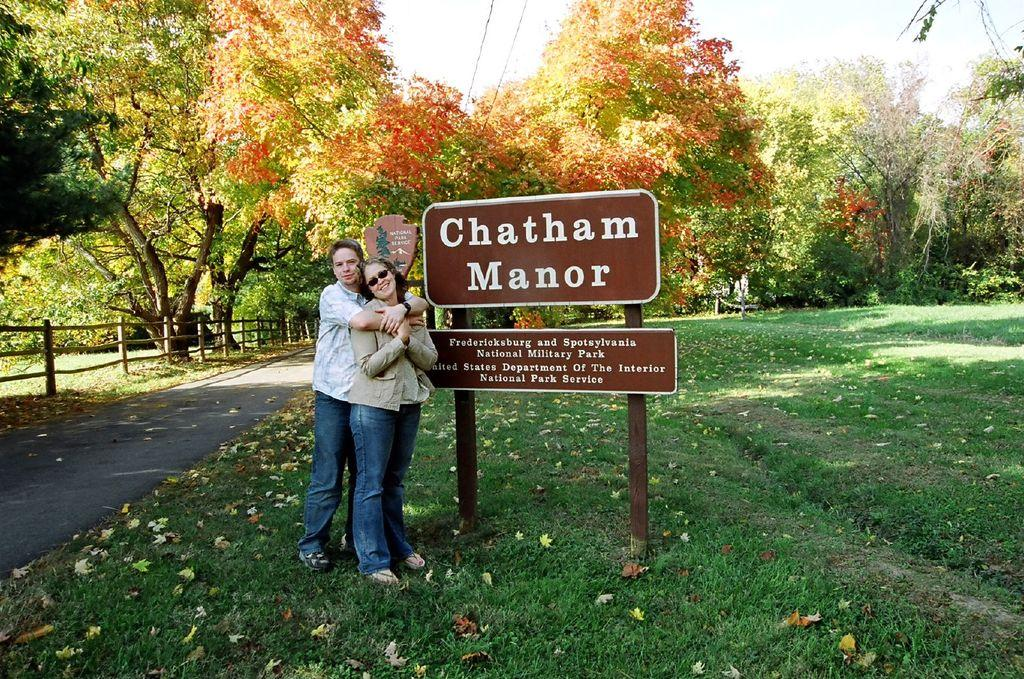How many people can be seen in the image? There are a few people in the image. What type of ground is visible in the image? The ground with grass is visible in the image. What other natural elements are present in the image? There are trees in the image. What man-made structures can be seen in the image? Wires, boards with text, and a fence are visible in the image. What part of the natural environment is visible in the image? The sky is visible in the image. What type of furniture is visible in the image? There is no furniture present in the image. How many gates can be seen in the image? There is no gate present in the image. 